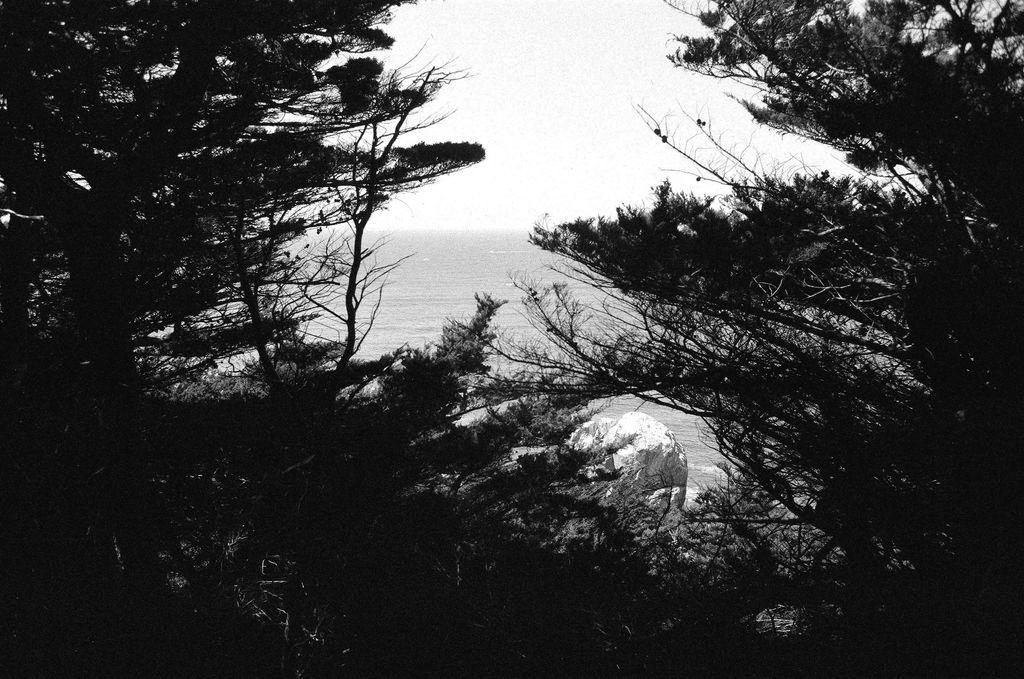What type of vegetation is present in the image? There are trees in the image. What is the small, solid object in the image? There is a stone in the image. What can be seen in the distance in the image? There is an ocean in the background of the image. What is visible above the trees and ocean in the image? The sky is visible in the background of the image. How does the image depict the level of pollution in the area? The image does not depict the level of pollution, as it is a black and white image of trees, a stone, an ocean, and the sky. What type of cast is visible in the image? There is no cast present in the image. 